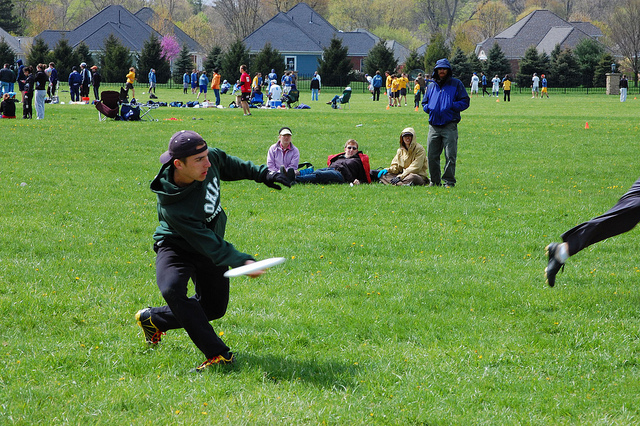Identify the text displayed in this image. OHI 